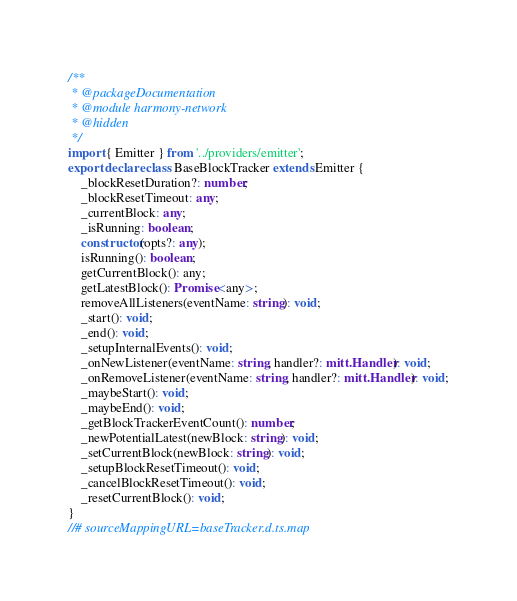<code> <loc_0><loc_0><loc_500><loc_500><_TypeScript_>/**
 * @packageDocumentation
 * @module harmony-network
 * @hidden
 */
import { Emitter } from '../providers/emitter';
export declare class BaseBlockTracker extends Emitter {
    _blockResetDuration?: number;
    _blockResetTimeout: any;
    _currentBlock: any;
    _isRunning: boolean;
    constructor(opts?: any);
    isRunning(): boolean;
    getCurrentBlock(): any;
    getLatestBlock(): Promise<any>;
    removeAllListeners(eventName: string): void;
    _start(): void;
    _end(): void;
    _setupInternalEvents(): void;
    _onNewListener(eventName: string, handler?: mitt.Handler): void;
    _onRemoveListener(eventName: string, handler?: mitt.Handler): void;
    _maybeStart(): void;
    _maybeEnd(): void;
    _getBlockTrackerEventCount(): number;
    _newPotentialLatest(newBlock: string): void;
    _setCurrentBlock(newBlock: string): void;
    _setupBlockResetTimeout(): void;
    _cancelBlockResetTimeout(): void;
    _resetCurrentBlock(): void;
}
//# sourceMappingURL=baseTracker.d.ts.map</code> 